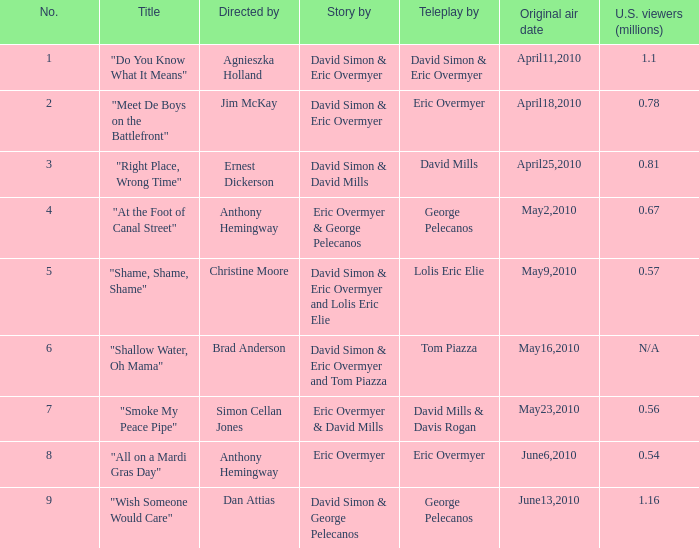Mention the united states spectators directed by christine moore. 0.57. 